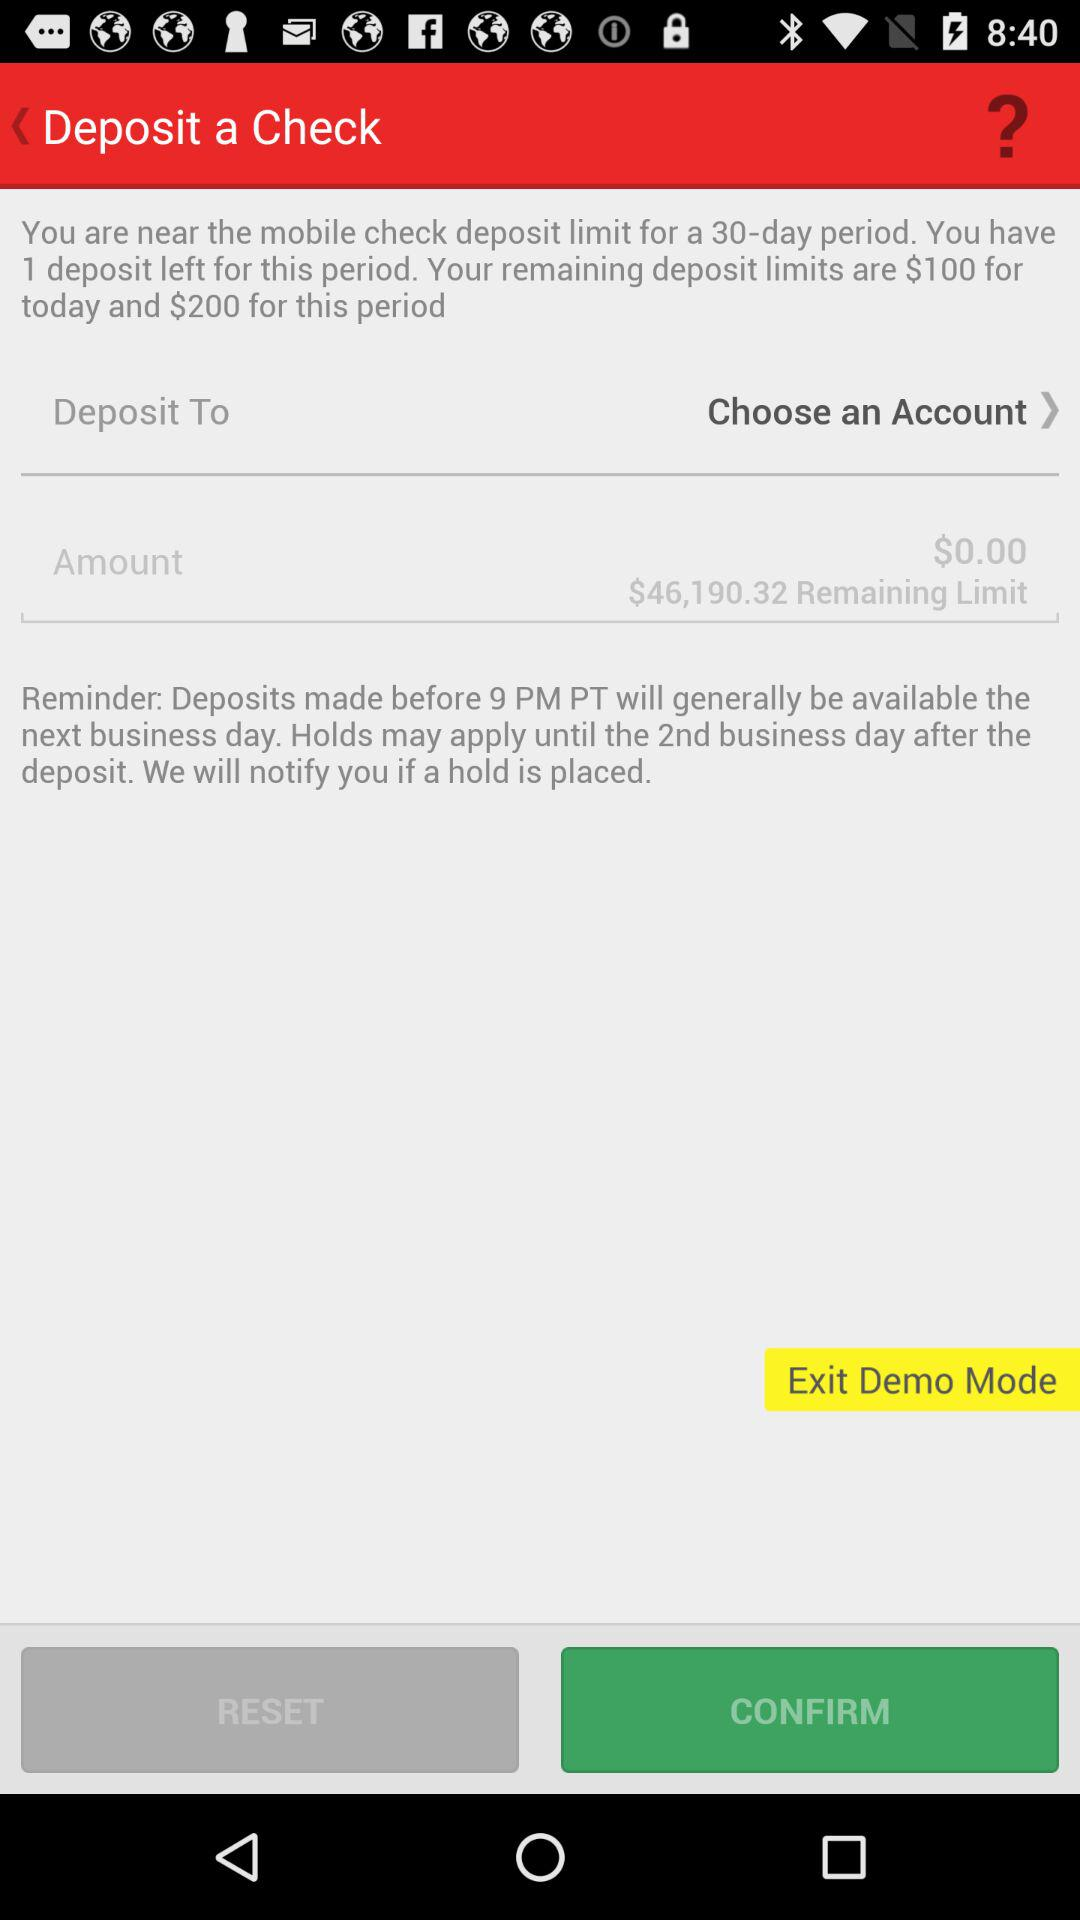Which account has been chosen?
When the provided information is insufficient, respond with <no answer>. <no answer> 